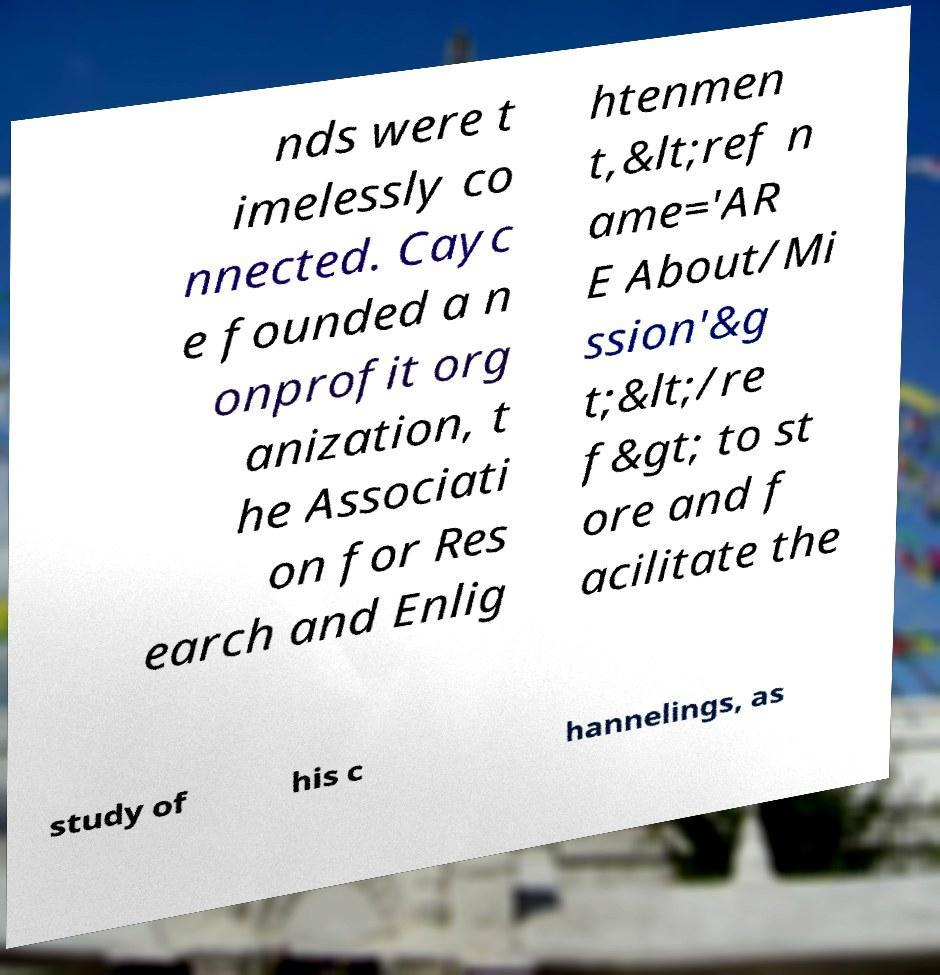There's text embedded in this image that I need extracted. Can you transcribe it verbatim? nds were t imelessly co nnected. Cayc e founded a n onprofit org anization, t he Associati on for Res earch and Enlig htenmen t,&lt;ref n ame='AR E About/Mi ssion'&g t;&lt;/re f&gt; to st ore and f acilitate the study of his c hannelings, as 